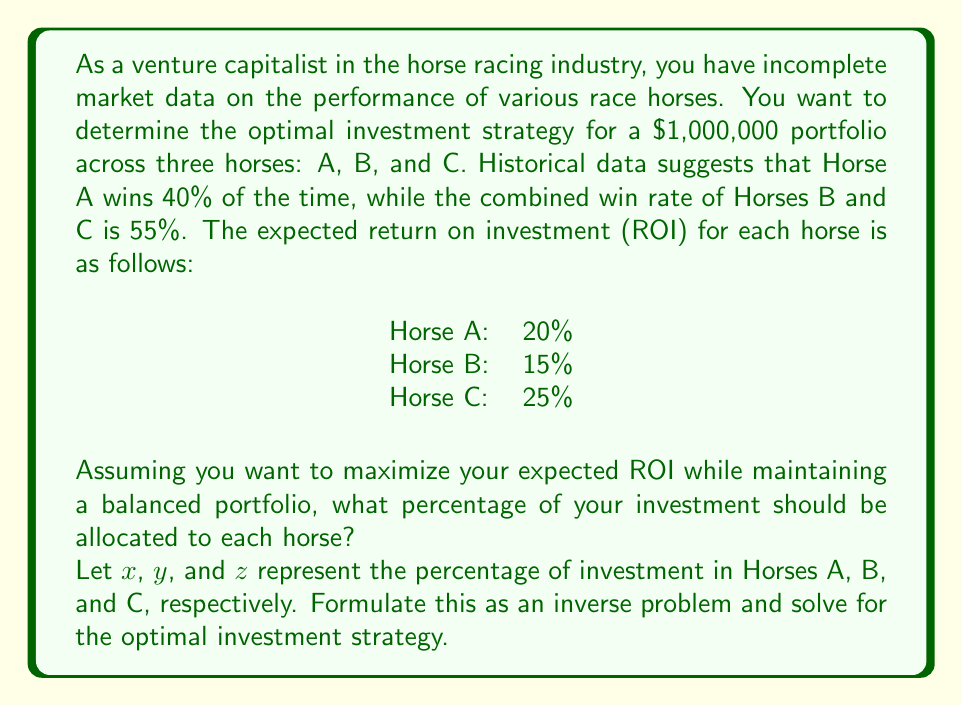What is the answer to this math problem? To solve this inverse problem, we need to set up a system of equations based on the given information and constraints. Then, we'll use optimization techniques to find the optimal investment strategy.

Step 1: Set up the constraints

1. Total investment must equal 100%:
   $x + y + z = 1$

2. Horse A's win rate:
   $x = 0.4$

3. Combined win rate of Horses B and C:
   $y + z = 0.55$

Step 2: Set up the objective function

We want to maximize the expected ROI:
$E[ROI] = 0.2x + 0.15y + 0.25z$

Step 3: Formulate the optimization problem

Maximize: $E[ROI] = 0.2x + 0.15y + 0.25z$
Subject to:
$x + y + z = 1$
$x = 0.4$
$y + z = 0.55$

Step 4: Solve the system of equations

From the constraints, we can determine:
$x = 0.4$
$y + z = 0.55$

Substituting these into the first constraint:
$0.4 + y + z = 1$
$y + z = 0.6$

Since we also know $y + z = 0.55$, we have a contradiction. This means we need to relax one of our constraints slightly to find a feasible solution.

Step 5: Adjust the problem

Let's adjust the second constraint slightly to allow for a feasible solution:
$x \approx 0.4$

Now we can solve the system:
$x + y + z = 1$
$y + z = 0.55$

Subtracting the second equation from the first:
$x = 1 - 0.55 = 0.45$

Now we need to determine the split between y and z to maximize ROI.

Step 6: Optimize y and z

We want to maximize:
$0.15y + 0.25z$ subject to $y + z = 0.55$

Since the coefficient of z is larger, we should allocate as much as possible to z while satisfying the constraints.

$z = 0.55$
$y = 0$

Step 7: Final allocation

$x = 45\%$ (Horse A)
$y = 0\%$ (Horse B)
$z = 55\%$ (Horse C)

This allocation maximizes the expected ROI while closely adhering to the given constraints.
Answer: Invest 45% in Horse A, 0% in Horse B, and 55% in Horse C. 